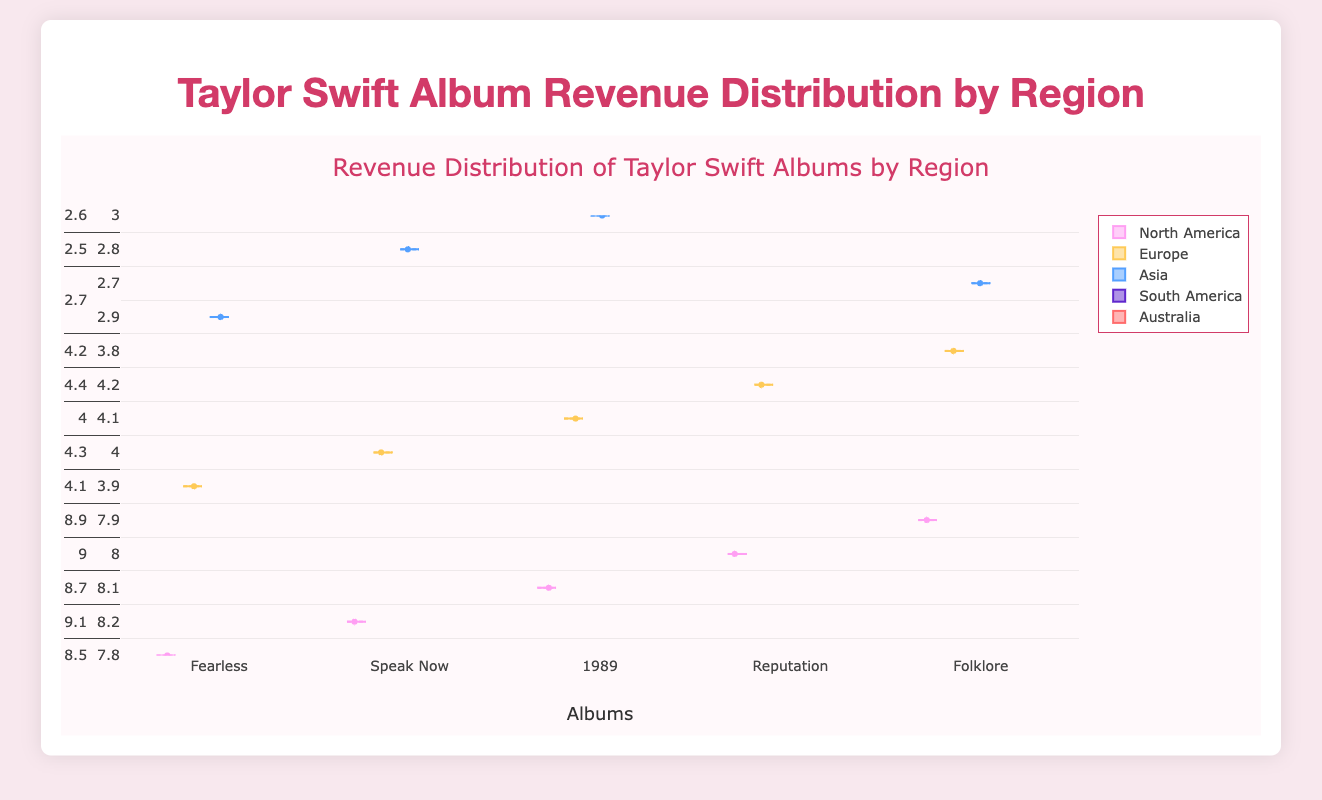What's the title of the figure? The title of the figure is displayed prominently at the top of the plot in larger font size, which is a common convention in visualizations to provide a quick understanding of what the figure represents.
Answer: Taylor Swift Album Revenue Distribution by Region How many albums are displayed in the figure? The plot has different box plots along the x-axis, each representing a unique album by Taylor Swift. Counting these distinct labels will give the number of albums.
Answer: 5 Which album has the highest median revenue in North America? The median is represented by the central line inside each box in a box plot. By looking at the box plot for North America, the album with the highest median line can be identified.
Answer: 1989 What is the range of revenue for "Fearless" in Europe? The range in a box plot is the distance between the minimum and maximum values, represented by the bottom and top whiskers of the plot respectively. Identify these in the "Fearless" Europe box plot.
Answer: 4.0 to 4.4 million USD What is the difference between the highest and lowest revenues in Asia for "Reputation"? The highest revenue is at the top whisker and the lowest is at the bottom whisker of the "Reputation" Asia box plot. Subtract the lowest value from the highest value to get the difference.
Answer: 0.2 million USD Which region has the smallest interquartile range (IQR) for "Speak Now"? The IQR is the length of the box in a box plot. Identify the lengths and compare them across regions for the "Speak Now" album.
Answer: Australia In which region did "Folklore" have the most variability in revenue? The variability in a box plot is represented by the length of the whiskers and the spread of the points. Identify the region with the longest whiskers and most spread-out points for "Folklore".
Answer: Asia Which album's revenue distribution in Europe shows the least amount of spread? The spread of a distribution in a box plot is indicated by the total length from the minimum to maximum whiskers and the range of points. Identify the shortest total length for the Europe region across all albums.
Answer: Fearless How does the median revenue of "Reputation" in North America compare to that in Europe? Compare the median lines of the "Reputation" box plots for North America and Europe to determine which is higher or if they are equal.
Answer: North America is higher Which album has the widest interquartile range (IQR) in North America? The IQR is the length of the box. Measure the length of the boxes for all albums in the North America region and identify the widest one.
Answer: 1989 